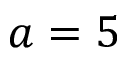Convert formula to latex. <formula><loc_0><loc_0><loc_500><loc_500>a = 5</formula> 